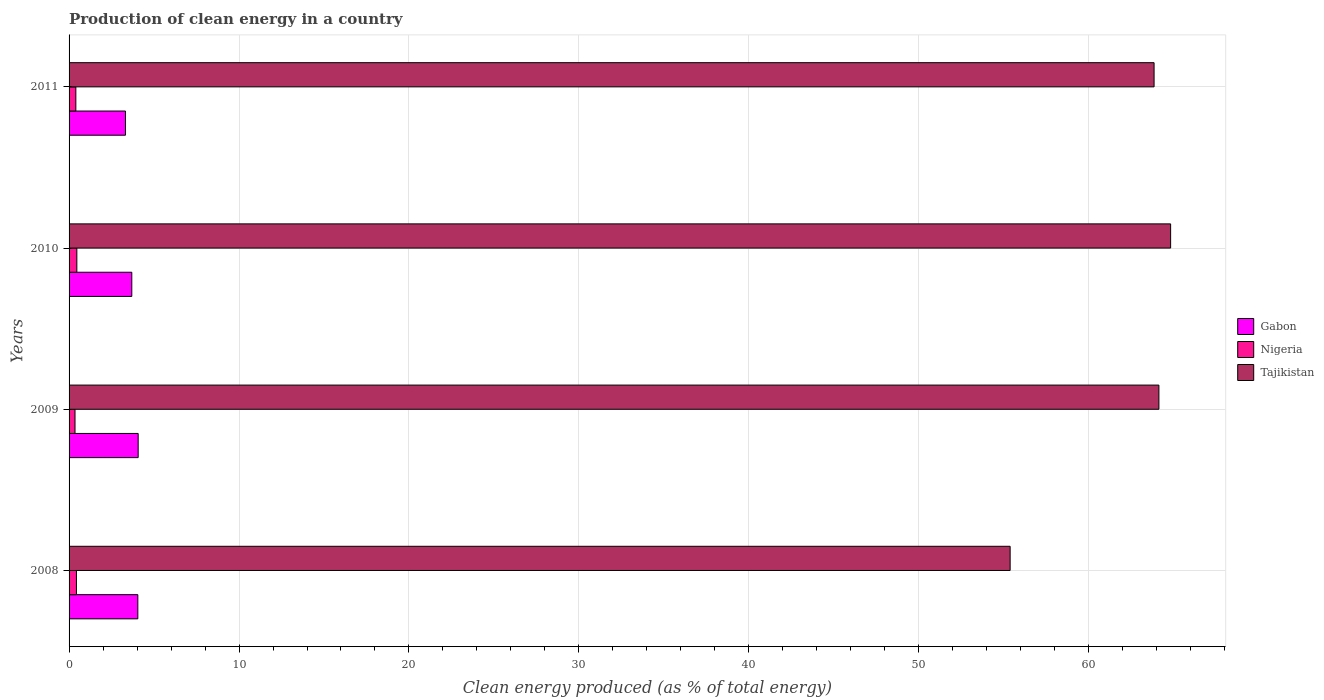Are the number of bars per tick equal to the number of legend labels?
Your answer should be very brief. Yes. How many bars are there on the 4th tick from the top?
Offer a terse response. 3. What is the percentage of clean energy produced in Gabon in 2011?
Give a very brief answer. 3.32. Across all years, what is the maximum percentage of clean energy produced in Gabon?
Your response must be concise. 4.07. Across all years, what is the minimum percentage of clean energy produced in Gabon?
Ensure brevity in your answer.  3.32. In which year was the percentage of clean energy produced in Nigeria minimum?
Ensure brevity in your answer.  2009. What is the total percentage of clean energy produced in Gabon in the graph?
Keep it short and to the point. 15.12. What is the difference between the percentage of clean energy produced in Gabon in 2010 and that in 2011?
Ensure brevity in your answer.  0.37. What is the difference between the percentage of clean energy produced in Nigeria in 2009 and the percentage of clean energy produced in Tajikistan in 2011?
Ensure brevity in your answer.  -63.49. What is the average percentage of clean energy produced in Tajikistan per year?
Provide a succinct answer. 62.04. In the year 2009, what is the difference between the percentage of clean energy produced in Gabon and percentage of clean energy produced in Nigeria?
Provide a succinct answer. 3.72. What is the ratio of the percentage of clean energy produced in Tajikistan in 2008 to that in 2011?
Offer a terse response. 0.87. Is the percentage of clean energy produced in Gabon in 2010 less than that in 2011?
Offer a terse response. No. What is the difference between the highest and the second highest percentage of clean energy produced in Nigeria?
Give a very brief answer. 0.02. What is the difference between the highest and the lowest percentage of clean energy produced in Gabon?
Provide a short and direct response. 0.75. What does the 2nd bar from the top in 2010 represents?
Keep it short and to the point. Nigeria. What does the 1st bar from the bottom in 2010 represents?
Provide a short and direct response. Gabon. How many bars are there?
Give a very brief answer. 12. Does the graph contain any zero values?
Keep it short and to the point. No. How many legend labels are there?
Your response must be concise. 3. What is the title of the graph?
Provide a short and direct response. Production of clean energy in a country. What is the label or title of the X-axis?
Offer a very short reply. Clean energy produced (as % of total energy). What is the Clean energy produced (as % of total energy) in Gabon in 2008?
Provide a short and direct response. 4.05. What is the Clean energy produced (as % of total energy) in Nigeria in 2008?
Ensure brevity in your answer.  0.43. What is the Clean energy produced (as % of total energy) in Tajikistan in 2008?
Keep it short and to the point. 55.37. What is the Clean energy produced (as % of total energy) in Gabon in 2009?
Your answer should be compact. 4.07. What is the Clean energy produced (as % of total energy) in Nigeria in 2009?
Make the answer very short. 0.35. What is the Clean energy produced (as % of total energy) in Tajikistan in 2009?
Make the answer very short. 64.13. What is the Clean energy produced (as % of total energy) in Gabon in 2010?
Provide a short and direct response. 3.69. What is the Clean energy produced (as % of total energy) in Nigeria in 2010?
Offer a very short reply. 0.46. What is the Clean energy produced (as % of total energy) of Tajikistan in 2010?
Keep it short and to the point. 64.82. What is the Clean energy produced (as % of total energy) in Gabon in 2011?
Your answer should be compact. 3.32. What is the Clean energy produced (as % of total energy) in Nigeria in 2011?
Make the answer very short. 0.4. What is the Clean energy produced (as % of total energy) in Tajikistan in 2011?
Your answer should be very brief. 63.84. Across all years, what is the maximum Clean energy produced (as % of total energy) in Gabon?
Keep it short and to the point. 4.07. Across all years, what is the maximum Clean energy produced (as % of total energy) in Nigeria?
Provide a succinct answer. 0.46. Across all years, what is the maximum Clean energy produced (as % of total energy) of Tajikistan?
Ensure brevity in your answer.  64.82. Across all years, what is the minimum Clean energy produced (as % of total energy) of Gabon?
Your answer should be compact. 3.32. Across all years, what is the minimum Clean energy produced (as % of total energy) in Nigeria?
Make the answer very short. 0.35. Across all years, what is the minimum Clean energy produced (as % of total energy) of Tajikistan?
Provide a succinct answer. 55.37. What is the total Clean energy produced (as % of total energy) of Gabon in the graph?
Your response must be concise. 15.12. What is the total Clean energy produced (as % of total energy) in Nigeria in the graph?
Offer a terse response. 1.64. What is the total Clean energy produced (as % of total energy) in Tajikistan in the graph?
Your answer should be compact. 248.16. What is the difference between the Clean energy produced (as % of total energy) in Gabon in 2008 and that in 2009?
Your answer should be very brief. -0.02. What is the difference between the Clean energy produced (as % of total energy) of Nigeria in 2008 and that in 2009?
Offer a terse response. 0.09. What is the difference between the Clean energy produced (as % of total energy) in Tajikistan in 2008 and that in 2009?
Give a very brief answer. -8.75. What is the difference between the Clean energy produced (as % of total energy) in Gabon in 2008 and that in 2010?
Ensure brevity in your answer.  0.35. What is the difference between the Clean energy produced (as % of total energy) in Nigeria in 2008 and that in 2010?
Your response must be concise. -0.02. What is the difference between the Clean energy produced (as % of total energy) in Tajikistan in 2008 and that in 2010?
Your response must be concise. -9.44. What is the difference between the Clean energy produced (as % of total energy) of Gabon in 2008 and that in 2011?
Your answer should be very brief. 0.73. What is the difference between the Clean energy produced (as % of total energy) in Nigeria in 2008 and that in 2011?
Ensure brevity in your answer.  0.04. What is the difference between the Clean energy produced (as % of total energy) in Tajikistan in 2008 and that in 2011?
Your response must be concise. -8.47. What is the difference between the Clean energy produced (as % of total energy) of Gabon in 2009 and that in 2010?
Offer a terse response. 0.38. What is the difference between the Clean energy produced (as % of total energy) in Nigeria in 2009 and that in 2010?
Offer a very short reply. -0.11. What is the difference between the Clean energy produced (as % of total energy) in Tajikistan in 2009 and that in 2010?
Provide a succinct answer. -0.69. What is the difference between the Clean energy produced (as % of total energy) of Gabon in 2009 and that in 2011?
Give a very brief answer. 0.75. What is the difference between the Clean energy produced (as % of total energy) of Nigeria in 2009 and that in 2011?
Offer a terse response. -0.05. What is the difference between the Clean energy produced (as % of total energy) in Tajikistan in 2009 and that in 2011?
Make the answer very short. 0.28. What is the difference between the Clean energy produced (as % of total energy) of Gabon in 2010 and that in 2011?
Ensure brevity in your answer.  0.37. What is the difference between the Clean energy produced (as % of total energy) of Nigeria in 2010 and that in 2011?
Offer a very short reply. 0.06. What is the difference between the Clean energy produced (as % of total energy) of Tajikistan in 2010 and that in 2011?
Your response must be concise. 0.97. What is the difference between the Clean energy produced (as % of total energy) of Gabon in 2008 and the Clean energy produced (as % of total energy) of Nigeria in 2009?
Make the answer very short. 3.7. What is the difference between the Clean energy produced (as % of total energy) in Gabon in 2008 and the Clean energy produced (as % of total energy) in Tajikistan in 2009?
Give a very brief answer. -60.08. What is the difference between the Clean energy produced (as % of total energy) of Nigeria in 2008 and the Clean energy produced (as % of total energy) of Tajikistan in 2009?
Keep it short and to the point. -63.69. What is the difference between the Clean energy produced (as % of total energy) in Gabon in 2008 and the Clean energy produced (as % of total energy) in Nigeria in 2010?
Make the answer very short. 3.59. What is the difference between the Clean energy produced (as % of total energy) in Gabon in 2008 and the Clean energy produced (as % of total energy) in Tajikistan in 2010?
Make the answer very short. -60.77. What is the difference between the Clean energy produced (as % of total energy) in Nigeria in 2008 and the Clean energy produced (as % of total energy) in Tajikistan in 2010?
Offer a terse response. -64.38. What is the difference between the Clean energy produced (as % of total energy) in Gabon in 2008 and the Clean energy produced (as % of total energy) in Nigeria in 2011?
Make the answer very short. 3.65. What is the difference between the Clean energy produced (as % of total energy) of Gabon in 2008 and the Clean energy produced (as % of total energy) of Tajikistan in 2011?
Offer a terse response. -59.8. What is the difference between the Clean energy produced (as % of total energy) in Nigeria in 2008 and the Clean energy produced (as % of total energy) in Tajikistan in 2011?
Your answer should be very brief. -63.41. What is the difference between the Clean energy produced (as % of total energy) in Gabon in 2009 and the Clean energy produced (as % of total energy) in Nigeria in 2010?
Your answer should be compact. 3.61. What is the difference between the Clean energy produced (as % of total energy) of Gabon in 2009 and the Clean energy produced (as % of total energy) of Tajikistan in 2010?
Make the answer very short. -60.75. What is the difference between the Clean energy produced (as % of total energy) of Nigeria in 2009 and the Clean energy produced (as % of total energy) of Tajikistan in 2010?
Provide a short and direct response. -64.47. What is the difference between the Clean energy produced (as % of total energy) of Gabon in 2009 and the Clean energy produced (as % of total energy) of Nigeria in 2011?
Ensure brevity in your answer.  3.67. What is the difference between the Clean energy produced (as % of total energy) in Gabon in 2009 and the Clean energy produced (as % of total energy) in Tajikistan in 2011?
Ensure brevity in your answer.  -59.78. What is the difference between the Clean energy produced (as % of total energy) of Nigeria in 2009 and the Clean energy produced (as % of total energy) of Tajikistan in 2011?
Ensure brevity in your answer.  -63.49. What is the difference between the Clean energy produced (as % of total energy) in Gabon in 2010 and the Clean energy produced (as % of total energy) in Nigeria in 2011?
Make the answer very short. 3.29. What is the difference between the Clean energy produced (as % of total energy) in Gabon in 2010 and the Clean energy produced (as % of total energy) in Tajikistan in 2011?
Ensure brevity in your answer.  -60.15. What is the difference between the Clean energy produced (as % of total energy) in Nigeria in 2010 and the Clean energy produced (as % of total energy) in Tajikistan in 2011?
Offer a very short reply. -63.39. What is the average Clean energy produced (as % of total energy) in Gabon per year?
Provide a short and direct response. 3.78. What is the average Clean energy produced (as % of total energy) of Nigeria per year?
Provide a short and direct response. 0.41. What is the average Clean energy produced (as % of total energy) in Tajikistan per year?
Your answer should be compact. 62.04. In the year 2008, what is the difference between the Clean energy produced (as % of total energy) of Gabon and Clean energy produced (as % of total energy) of Nigeria?
Keep it short and to the point. 3.61. In the year 2008, what is the difference between the Clean energy produced (as % of total energy) in Gabon and Clean energy produced (as % of total energy) in Tajikistan?
Offer a terse response. -51.33. In the year 2008, what is the difference between the Clean energy produced (as % of total energy) of Nigeria and Clean energy produced (as % of total energy) of Tajikistan?
Your response must be concise. -54.94. In the year 2009, what is the difference between the Clean energy produced (as % of total energy) of Gabon and Clean energy produced (as % of total energy) of Nigeria?
Your answer should be compact. 3.72. In the year 2009, what is the difference between the Clean energy produced (as % of total energy) of Gabon and Clean energy produced (as % of total energy) of Tajikistan?
Your response must be concise. -60.06. In the year 2009, what is the difference between the Clean energy produced (as % of total energy) of Nigeria and Clean energy produced (as % of total energy) of Tajikistan?
Your answer should be compact. -63.78. In the year 2010, what is the difference between the Clean energy produced (as % of total energy) of Gabon and Clean energy produced (as % of total energy) of Nigeria?
Your answer should be compact. 3.23. In the year 2010, what is the difference between the Clean energy produced (as % of total energy) in Gabon and Clean energy produced (as % of total energy) in Tajikistan?
Offer a terse response. -61.13. In the year 2010, what is the difference between the Clean energy produced (as % of total energy) of Nigeria and Clean energy produced (as % of total energy) of Tajikistan?
Ensure brevity in your answer.  -64.36. In the year 2011, what is the difference between the Clean energy produced (as % of total energy) of Gabon and Clean energy produced (as % of total energy) of Nigeria?
Ensure brevity in your answer.  2.92. In the year 2011, what is the difference between the Clean energy produced (as % of total energy) of Gabon and Clean energy produced (as % of total energy) of Tajikistan?
Your answer should be very brief. -60.53. In the year 2011, what is the difference between the Clean energy produced (as % of total energy) in Nigeria and Clean energy produced (as % of total energy) in Tajikistan?
Make the answer very short. -63.45. What is the ratio of the Clean energy produced (as % of total energy) in Gabon in 2008 to that in 2009?
Offer a very short reply. 0.99. What is the ratio of the Clean energy produced (as % of total energy) in Nigeria in 2008 to that in 2009?
Your response must be concise. 1.24. What is the ratio of the Clean energy produced (as % of total energy) of Tajikistan in 2008 to that in 2009?
Your answer should be compact. 0.86. What is the ratio of the Clean energy produced (as % of total energy) in Gabon in 2008 to that in 2010?
Offer a terse response. 1.1. What is the ratio of the Clean energy produced (as % of total energy) of Nigeria in 2008 to that in 2010?
Offer a very short reply. 0.95. What is the ratio of the Clean energy produced (as % of total energy) of Tajikistan in 2008 to that in 2010?
Give a very brief answer. 0.85. What is the ratio of the Clean energy produced (as % of total energy) of Gabon in 2008 to that in 2011?
Keep it short and to the point. 1.22. What is the ratio of the Clean energy produced (as % of total energy) of Nigeria in 2008 to that in 2011?
Provide a short and direct response. 1.09. What is the ratio of the Clean energy produced (as % of total energy) in Tajikistan in 2008 to that in 2011?
Your response must be concise. 0.87. What is the ratio of the Clean energy produced (as % of total energy) in Gabon in 2009 to that in 2010?
Make the answer very short. 1.1. What is the ratio of the Clean energy produced (as % of total energy) of Nigeria in 2009 to that in 2010?
Your response must be concise. 0.76. What is the ratio of the Clean energy produced (as % of total energy) of Tajikistan in 2009 to that in 2010?
Provide a succinct answer. 0.99. What is the ratio of the Clean energy produced (as % of total energy) of Gabon in 2009 to that in 2011?
Make the answer very short. 1.23. What is the ratio of the Clean energy produced (as % of total energy) in Nigeria in 2009 to that in 2011?
Give a very brief answer. 0.88. What is the ratio of the Clean energy produced (as % of total energy) in Tajikistan in 2009 to that in 2011?
Make the answer very short. 1. What is the ratio of the Clean energy produced (as % of total energy) in Gabon in 2010 to that in 2011?
Ensure brevity in your answer.  1.11. What is the ratio of the Clean energy produced (as % of total energy) in Nigeria in 2010 to that in 2011?
Offer a very short reply. 1.15. What is the ratio of the Clean energy produced (as % of total energy) of Tajikistan in 2010 to that in 2011?
Provide a succinct answer. 1.02. What is the difference between the highest and the second highest Clean energy produced (as % of total energy) in Gabon?
Provide a short and direct response. 0.02. What is the difference between the highest and the second highest Clean energy produced (as % of total energy) of Nigeria?
Your answer should be very brief. 0.02. What is the difference between the highest and the second highest Clean energy produced (as % of total energy) in Tajikistan?
Your answer should be compact. 0.69. What is the difference between the highest and the lowest Clean energy produced (as % of total energy) of Gabon?
Ensure brevity in your answer.  0.75. What is the difference between the highest and the lowest Clean energy produced (as % of total energy) of Nigeria?
Your response must be concise. 0.11. What is the difference between the highest and the lowest Clean energy produced (as % of total energy) of Tajikistan?
Offer a very short reply. 9.44. 